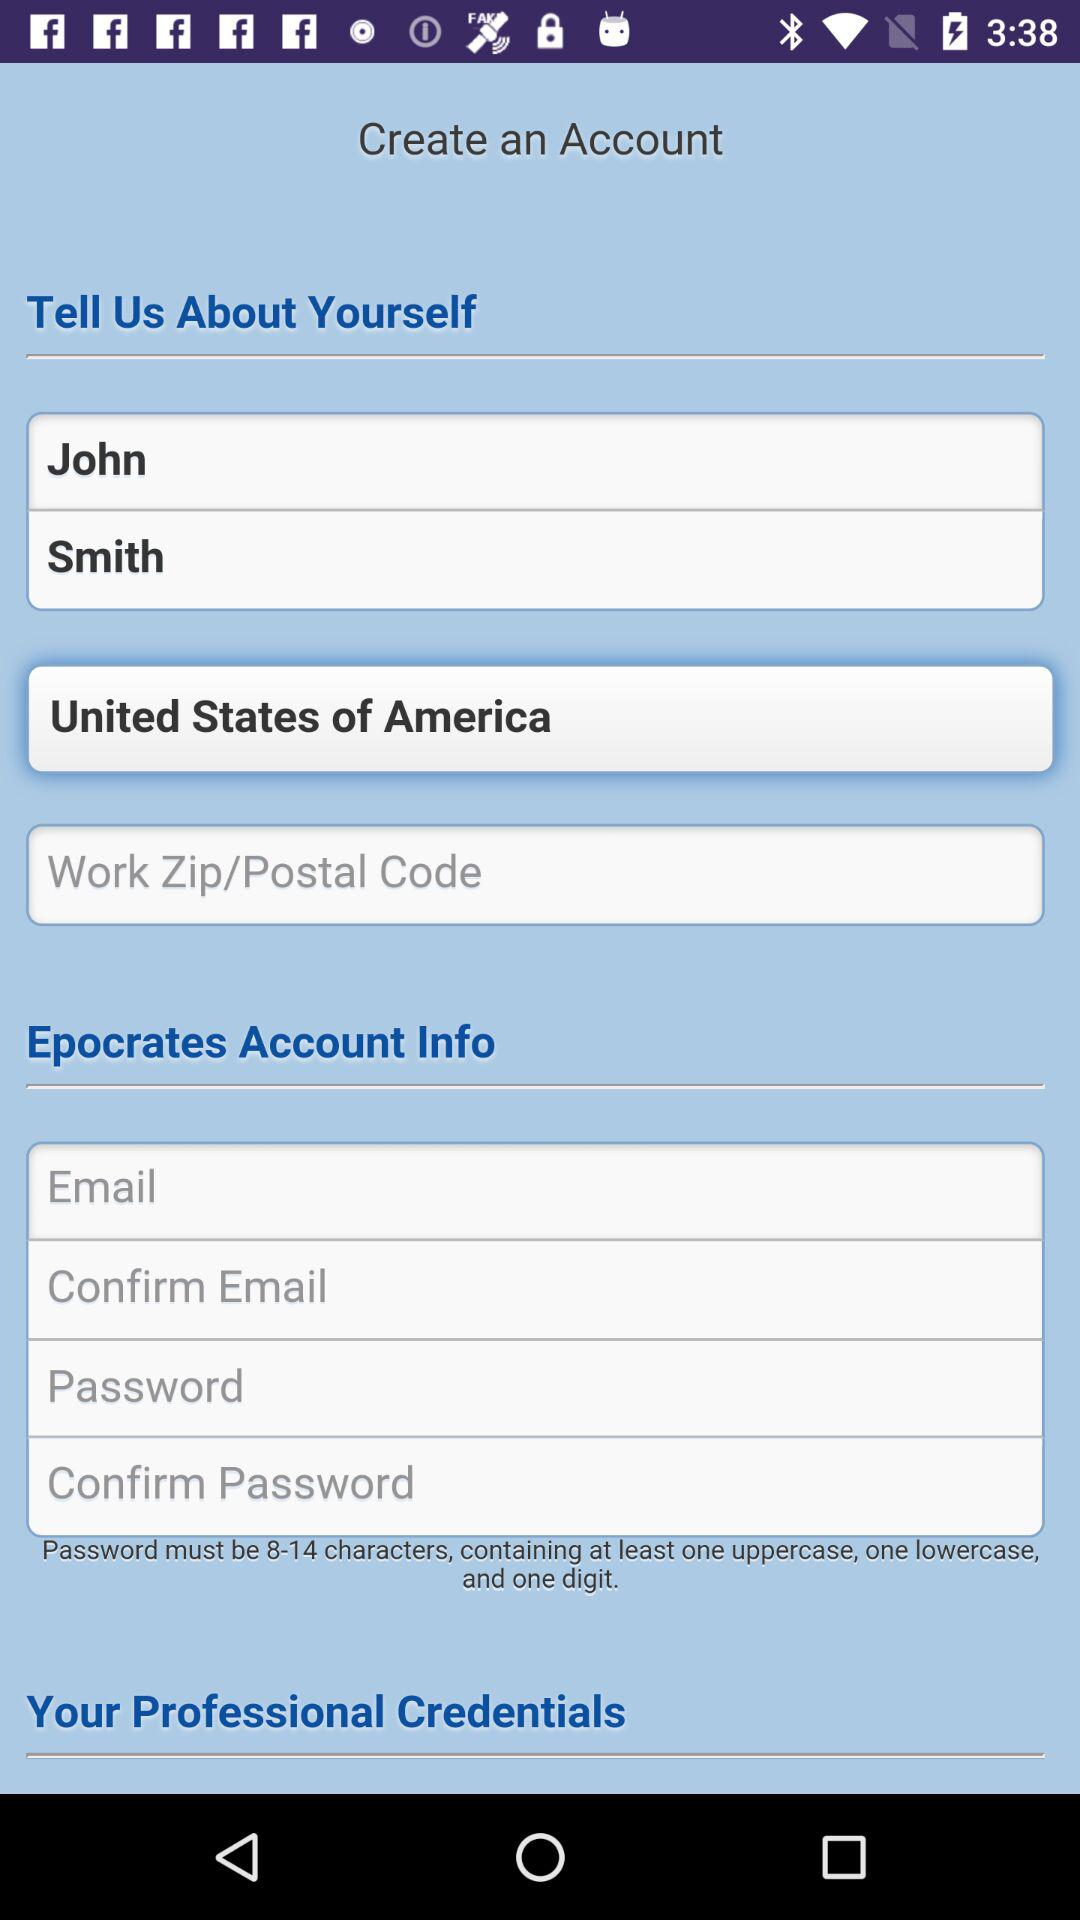What is the name of the user? The name of the user is John Smith. 